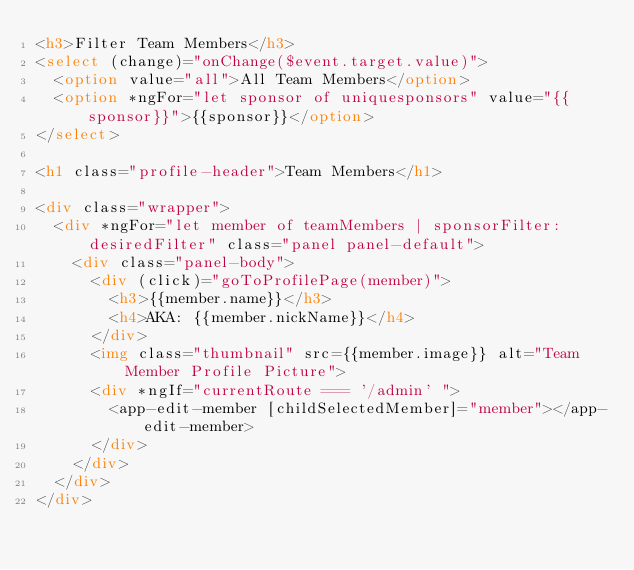Convert code to text. <code><loc_0><loc_0><loc_500><loc_500><_HTML_><h3>Filter Team Members</h3>
<select (change)="onChange($event.target.value)">
  <option value="all">All Team Members</option>
  <option *ngFor="let sponsor of uniquesponsors" value="{{sponsor}}">{{sponsor}}</option>
</select>

<h1 class="profile-header">Team Members</h1>

<div class="wrapper">
  <div *ngFor="let member of teamMembers | sponsorFilter:desiredFilter" class="panel panel-default">
    <div class="panel-body">
      <div (click)="goToProfilePage(member)">
        <h3>{{member.name}}</h3>
        <h4>AKA: {{member.nickName}}</h4>
      </div>
      <img class="thumbnail" src={{member.image}} alt="Team Member Profile Picture">
      <div *ngIf="currentRoute === '/admin' ">
        <app-edit-member [childSelectedMember]="member"></app-edit-member>
      </div>
    </div>
  </div>
</div>
</code> 